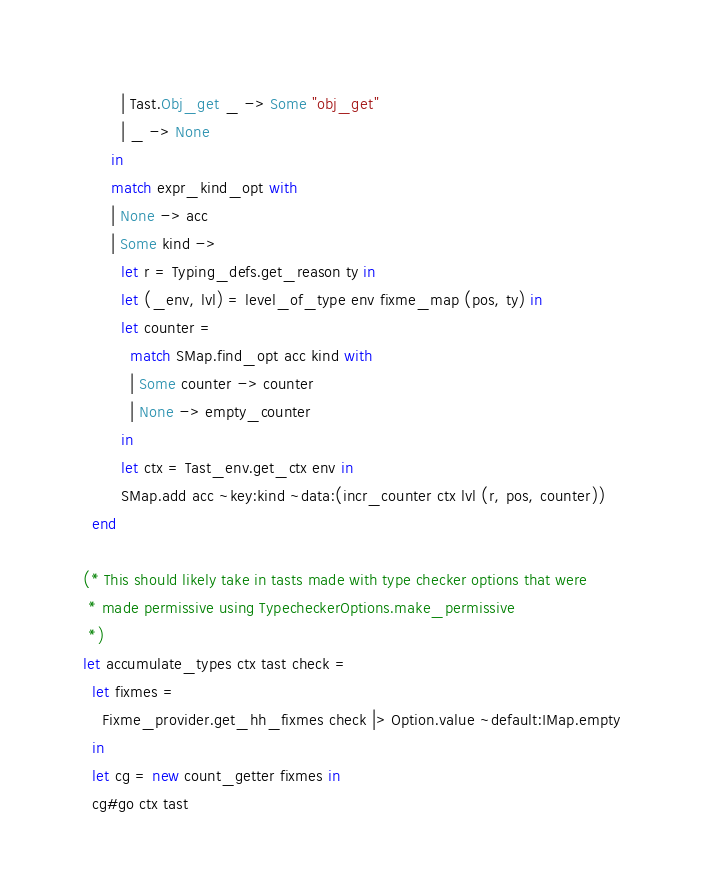<code> <loc_0><loc_0><loc_500><loc_500><_OCaml_>        | Tast.Obj_get _ -> Some "obj_get"
        | _ -> None
      in
      match expr_kind_opt with
      | None -> acc
      | Some kind ->
        let r = Typing_defs.get_reason ty in
        let (_env, lvl) = level_of_type env fixme_map (pos, ty) in
        let counter =
          match SMap.find_opt acc kind with
          | Some counter -> counter
          | None -> empty_counter
        in
        let ctx = Tast_env.get_ctx env in
        SMap.add acc ~key:kind ~data:(incr_counter ctx lvl (r, pos, counter))
  end

(* This should likely take in tasts made with type checker options that were
 * made permissive using TypecheckerOptions.make_permissive
 *)
let accumulate_types ctx tast check =
  let fixmes =
    Fixme_provider.get_hh_fixmes check |> Option.value ~default:IMap.empty
  in
  let cg = new count_getter fixmes in
  cg#go ctx tast
</code> 